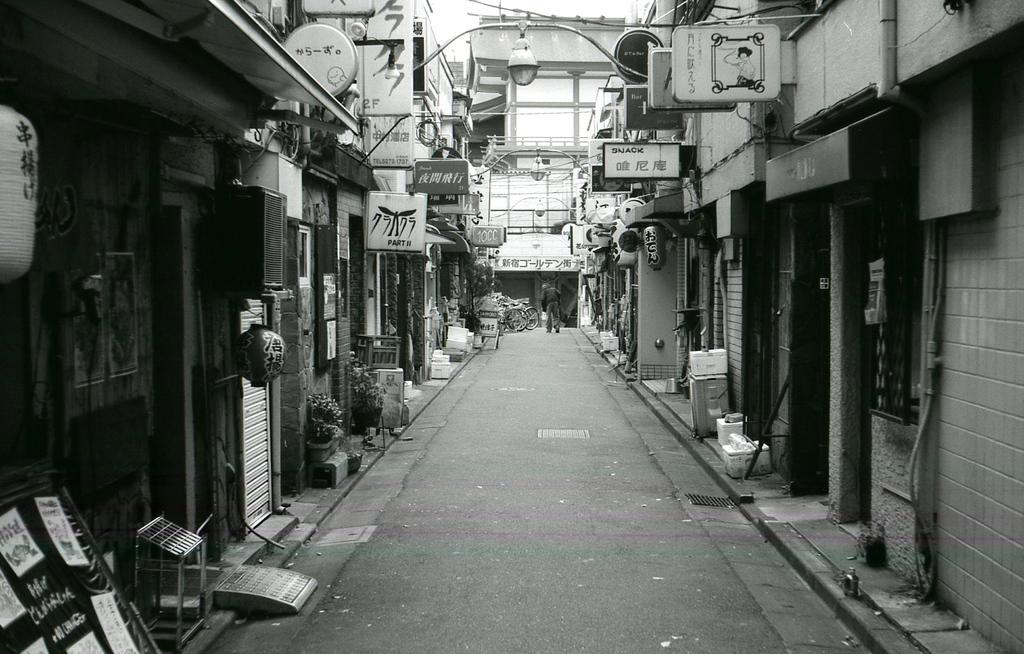What type of structures are present in the image? There are buildings in the image. What objects can be seen near the buildings? There are boards, flower pots, bicycles, and light poles in the image. Is there any sign of human presence in the image? Yes, a person is walking in the image. What is the color scheme of the image? The image is in black and white. Can you see a drum being played in the image? There is no drum present in the image. What type of van is parked near the light poles in the image? There is no van present in the image. 